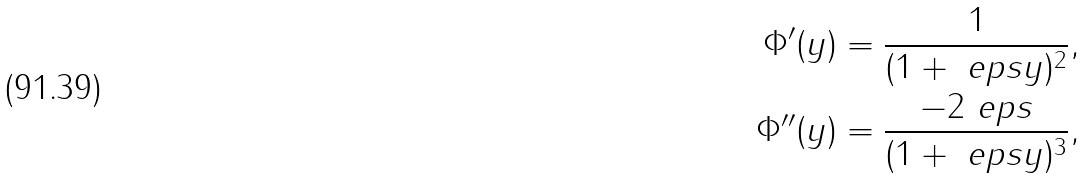Convert formula to latex. <formula><loc_0><loc_0><loc_500><loc_500>\Phi ^ { \prime } ( y ) & = \frac { 1 } { ( 1 + \ e p s y ) ^ { 2 } } , \\ \Phi ^ { \prime \prime } ( y ) & = \frac { - 2 \ e p s } { ( 1 + \ e p s y ) ^ { 3 } } ,</formula> 